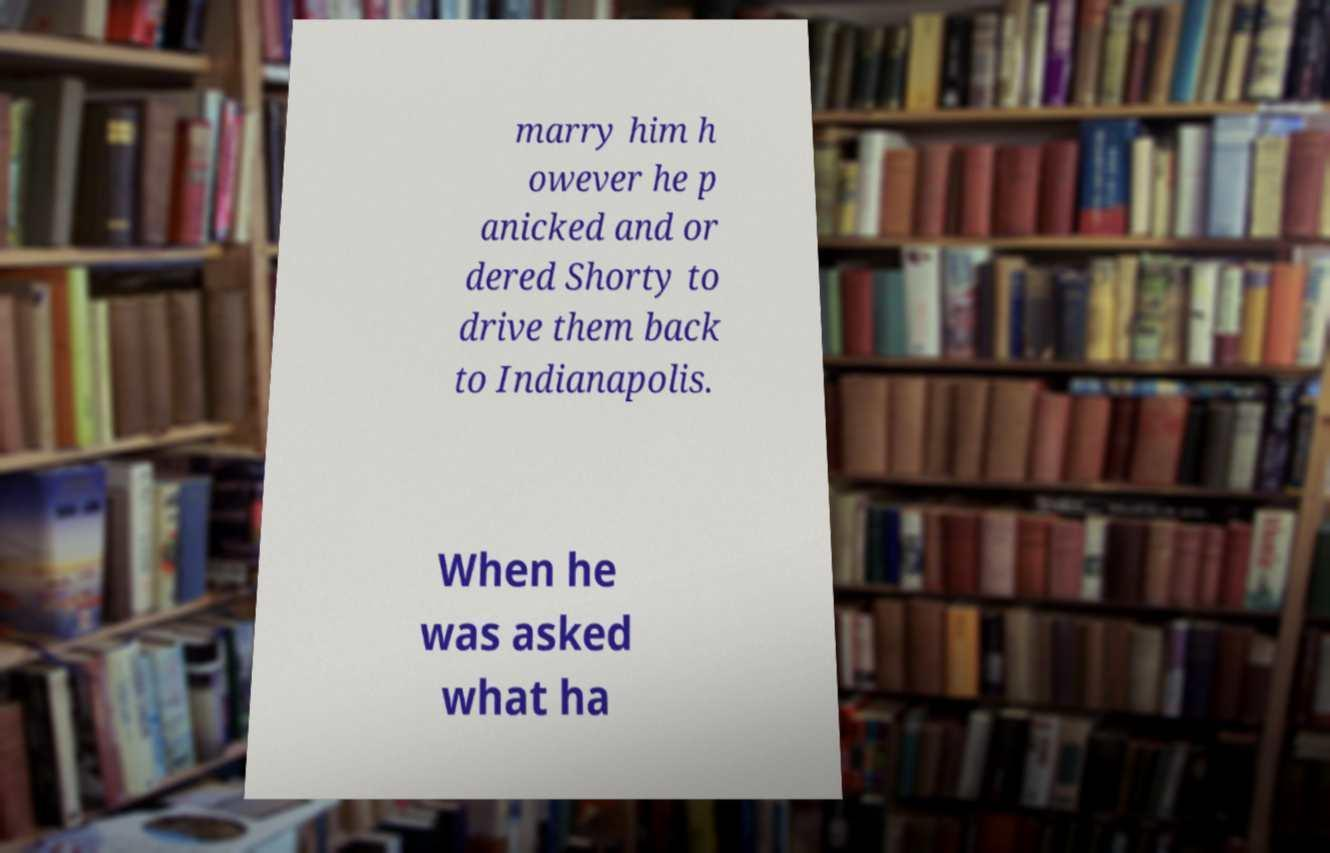Could you extract and type out the text from this image? marry him h owever he p anicked and or dered Shorty to drive them back to Indianapolis. When he was asked what ha 